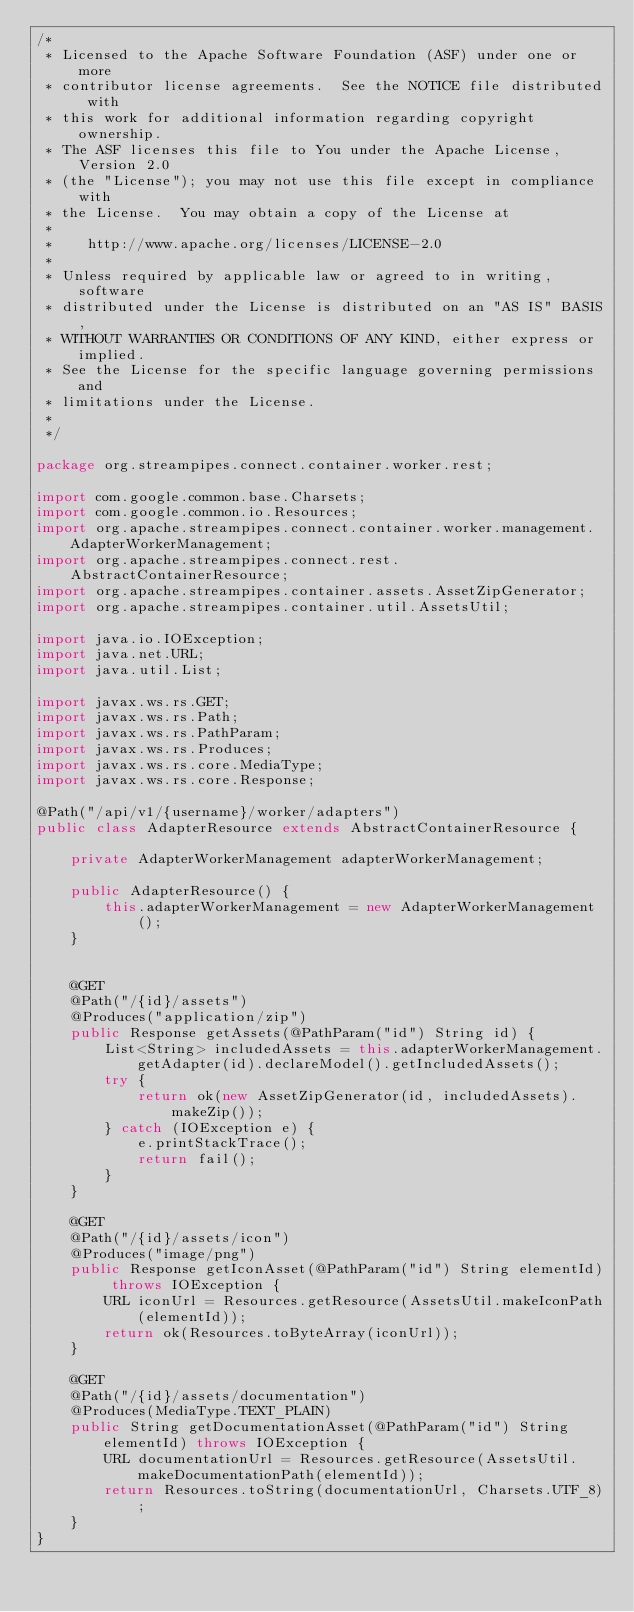Convert code to text. <code><loc_0><loc_0><loc_500><loc_500><_Java_>/*
 * Licensed to the Apache Software Foundation (ASF) under one or more
 * contributor license agreements.  See the NOTICE file distributed with
 * this work for additional information regarding copyright ownership.
 * The ASF licenses this file to You under the Apache License, Version 2.0
 * (the "License"); you may not use this file except in compliance with
 * the License.  You may obtain a copy of the License at
 *
 *    http://www.apache.org/licenses/LICENSE-2.0
 *
 * Unless required by applicable law or agreed to in writing, software
 * distributed under the License is distributed on an "AS IS" BASIS,
 * WITHOUT WARRANTIES OR CONDITIONS OF ANY KIND, either express or implied.
 * See the License for the specific language governing permissions and
 * limitations under the License.
 *
 */

package org.streampipes.connect.container.worker.rest;

import com.google.common.base.Charsets;
import com.google.common.io.Resources;
import org.apache.streampipes.connect.container.worker.management.AdapterWorkerManagement;
import org.apache.streampipes.connect.rest.AbstractContainerResource;
import org.apache.streampipes.container.assets.AssetZipGenerator;
import org.apache.streampipes.container.util.AssetsUtil;

import java.io.IOException;
import java.net.URL;
import java.util.List;

import javax.ws.rs.GET;
import javax.ws.rs.Path;
import javax.ws.rs.PathParam;
import javax.ws.rs.Produces;
import javax.ws.rs.core.MediaType;
import javax.ws.rs.core.Response;

@Path("/api/v1/{username}/worker/adapters")
public class AdapterResource extends AbstractContainerResource {

    private AdapterWorkerManagement adapterWorkerManagement;

    public AdapterResource() {
        this.adapterWorkerManagement = new AdapterWorkerManagement();
    }


    @GET
    @Path("/{id}/assets")
    @Produces("application/zip")
    public Response getAssets(@PathParam("id") String id) {
        List<String> includedAssets = this.adapterWorkerManagement.getAdapter(id).declareModel().getIncludedAssets();
        try {
            return ok(new AssetZipGenerator(id, includedAssets).makeZip());
        } catch (IOException e) {
            e.printStackTrace();
            return fail();
        }
    }

    @GET
    @Path("/{id}/assets/icon")
    @Produces("image/png")
    public Response getIconAsset(@PathParam("id") String elementId) throws IOException {
        URL iconUrl = Resources.getResource(AssetsUtil.makeIconPath(elementId));
        return ok(Resources.toByteArray(iconUrl));
    }

    @GET
    @Path("/{id}/assets/documentation")
    @Produces(MediaType.TEXT_PLAIN)
    public String getDocumentationAsset(@PathParam("id") String elementId) throws IOException {
        URL documentationUrl = Resources.getResource(AssetsUtil.makeDocumentationPath(elementId));
        return Resources.toString(documentationUrl, Charsets.UTF_8);
    }
}
</code> 